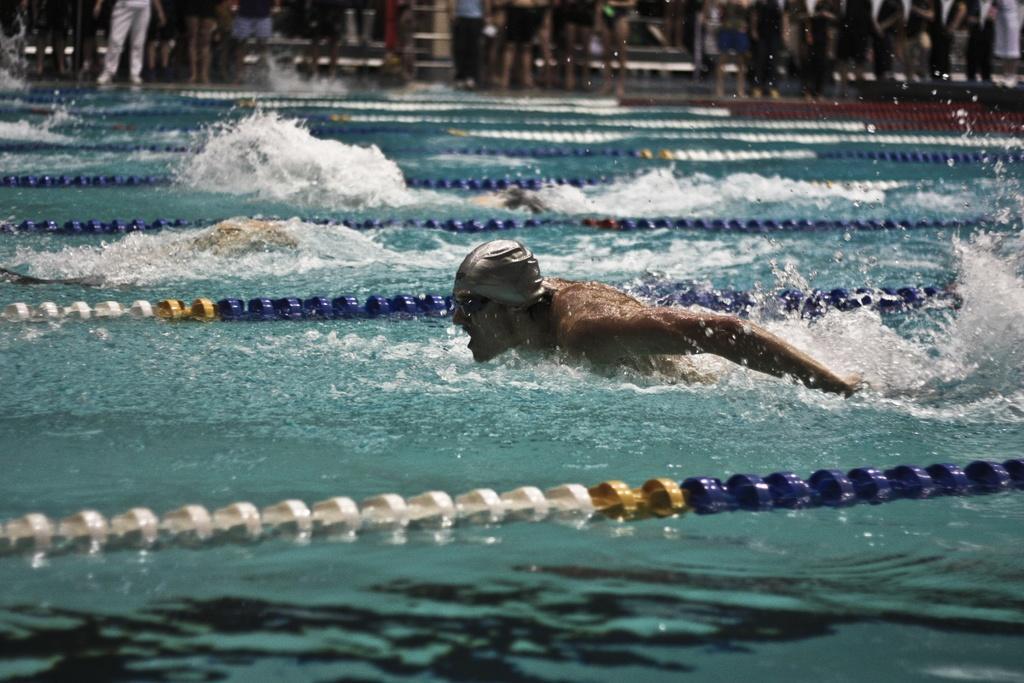How would you summarize this image in a sentence or two? Here in this picture we can see a group of people swimming in a pool, which is filled with water over there and in the front we can see the person is wearing cap and goggles on him and in the far we can see number of people standing and watching them. 